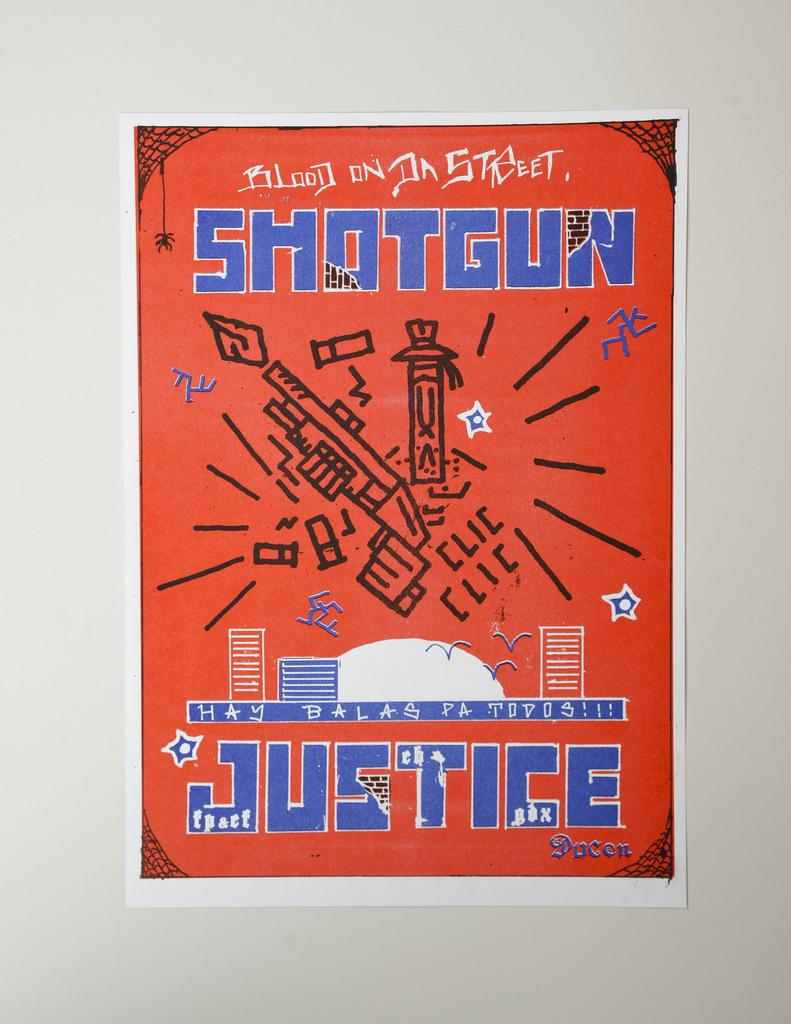<image>
Summarize the visual content of the image. Poster that says the word Justice on the bottom. 